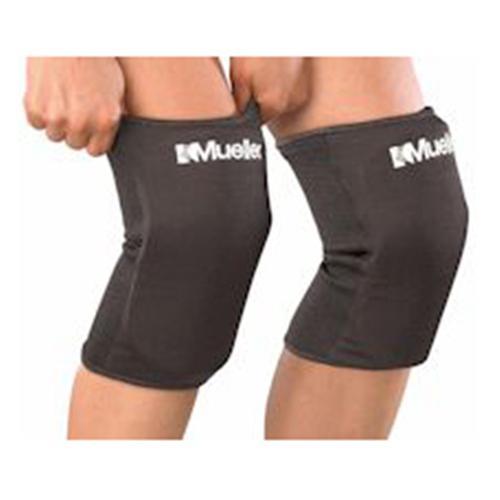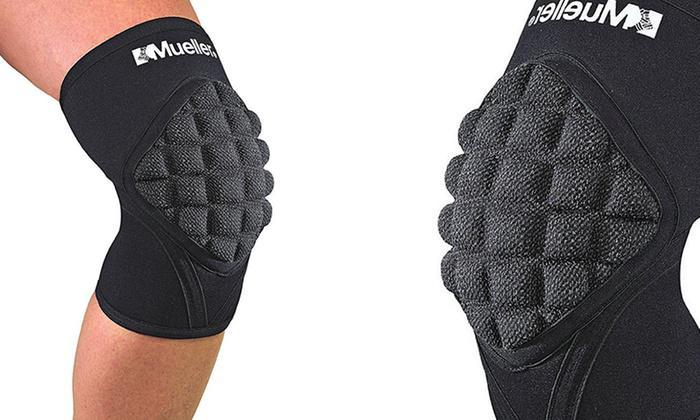The first image is the image on the left, the second image is the image on the right. Evaluate the accuracy of this statement regarding the images: "The pads are demonstrated on at least one leg.". Is it true? Answer yes or no. Yes. 